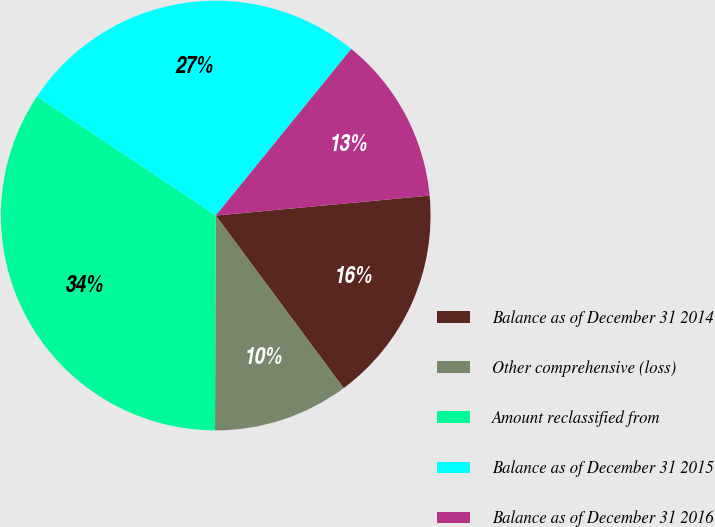Convert chart to OTSL. <chart><loc_0><loc_0><loc_500><loc_500><pie_chart><fcel>Balance as of December 31 2014<fcel>Other comprehensive (loss)<fcel>Amount reclassified from<fcel>Balance as of December 31 2015<fcel>Balance as of December 31 2016<nl><fcel>16.33%<fcel>10.2%<fcel>34.29%<fcel>26.53%<fcel>12.65%<nl></chart> 